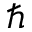<formula> <loc_0><loc_0><loc_500><loc_500>\hbar</formula> 